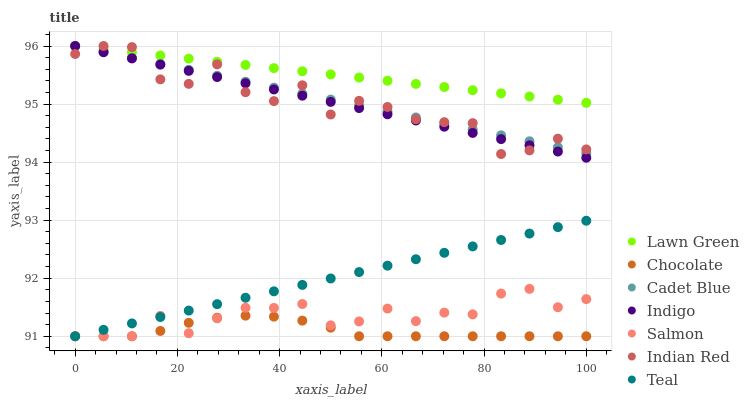Does Chocolate have the minimum area under the curve?
Answer yes or no. Yes. Does Lawn Green have the maximum area under the curve?
Answer yes or no. Yes. Does Cadet Blue have the minimum area under the curve?
Answer yes or no. No. Does Cadet Blue have the maximum area under the curve?
Answer yes or no. No. Is Teal the smoothest?
Answer yes or no. Yes. Is Indian Red the roughest?
Answer yes or no. Yes. Is Cadet Blue the smoothest?
Answer yes or no. No. Is Cadet Blue the roughest?
Answer yes or no. No. Does Teal have the lowest value?
Answer yes or no. Yes. Does Cadet Blue have the lowest value?
Answer yes or no. No. Does Indian Red have the highest value?
Answer yes or no. Yes. Does Teal have the highest value?
Answer yes or no. No. Is Chocolate less than Lawn Green?
Answer yes or no. Yes. Is Indian Red greater than Salmon?
Answer yes or no. Yes. Does Indian Red intersect Lawn Green?
Answer yes or no. Yes. Is Indian Red less than Lawn Green?
Answer yes or no. No. Is Indian Red greater than Lawn Green?
Answer yes or no. No. Does Chocolate intersect Lawn Green?
Answer yes or no. No. 